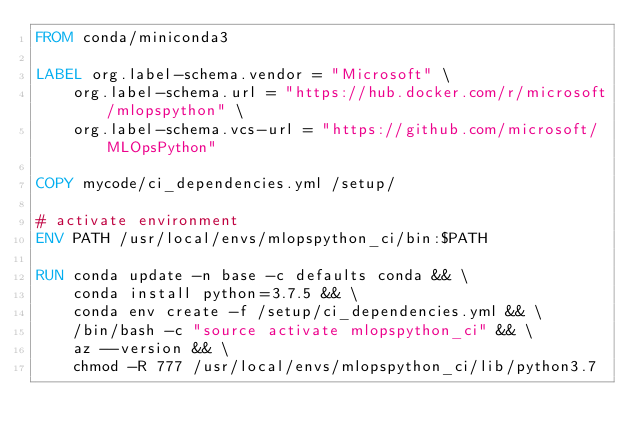Convert code to text. <code><loc_0><loc_0><loc_500><loc_500><_Dockerfile_>FROM conda/miniconda3

LABEL org.label-schema.vendor = "Microsoft" \
    org.label-schema.url = "https://hub.docker.com/r/microsoft/mlopspython" \
    org.label-schema.vcs-url = "https://github.com/microsoft/MLOpsPython"

COPY mycode/ci_dependencies.yml /setup/

# activate environment
ENV PATH /usr/local/envs/mlopspython_ci/bin:$PATH

RUN conda update -n base -c defaults conda && \
    conda install python=3.7.5 && \
    conda env create -f /setup/ci_dependencies.yml && \
    /bin/bash -c "source activate mlopspython_ci" && \
    az --version && \
    chmod -R 777 /usr/local/envs/mlopspython_ci/lib/python3.7
</code> 